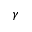<formula> <loc_0><loc_0><loc_500><loc_500>\gamma</formula> 